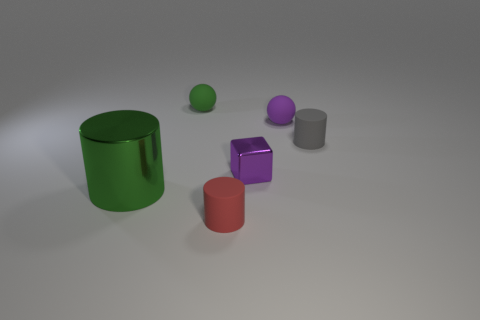Are there any reflective surfaces present? Yes, the objects have reflective surfaces as indicated by the highlights and reflections on them, which suggest the material could possibly be metal or plastic with a shiny finish. 